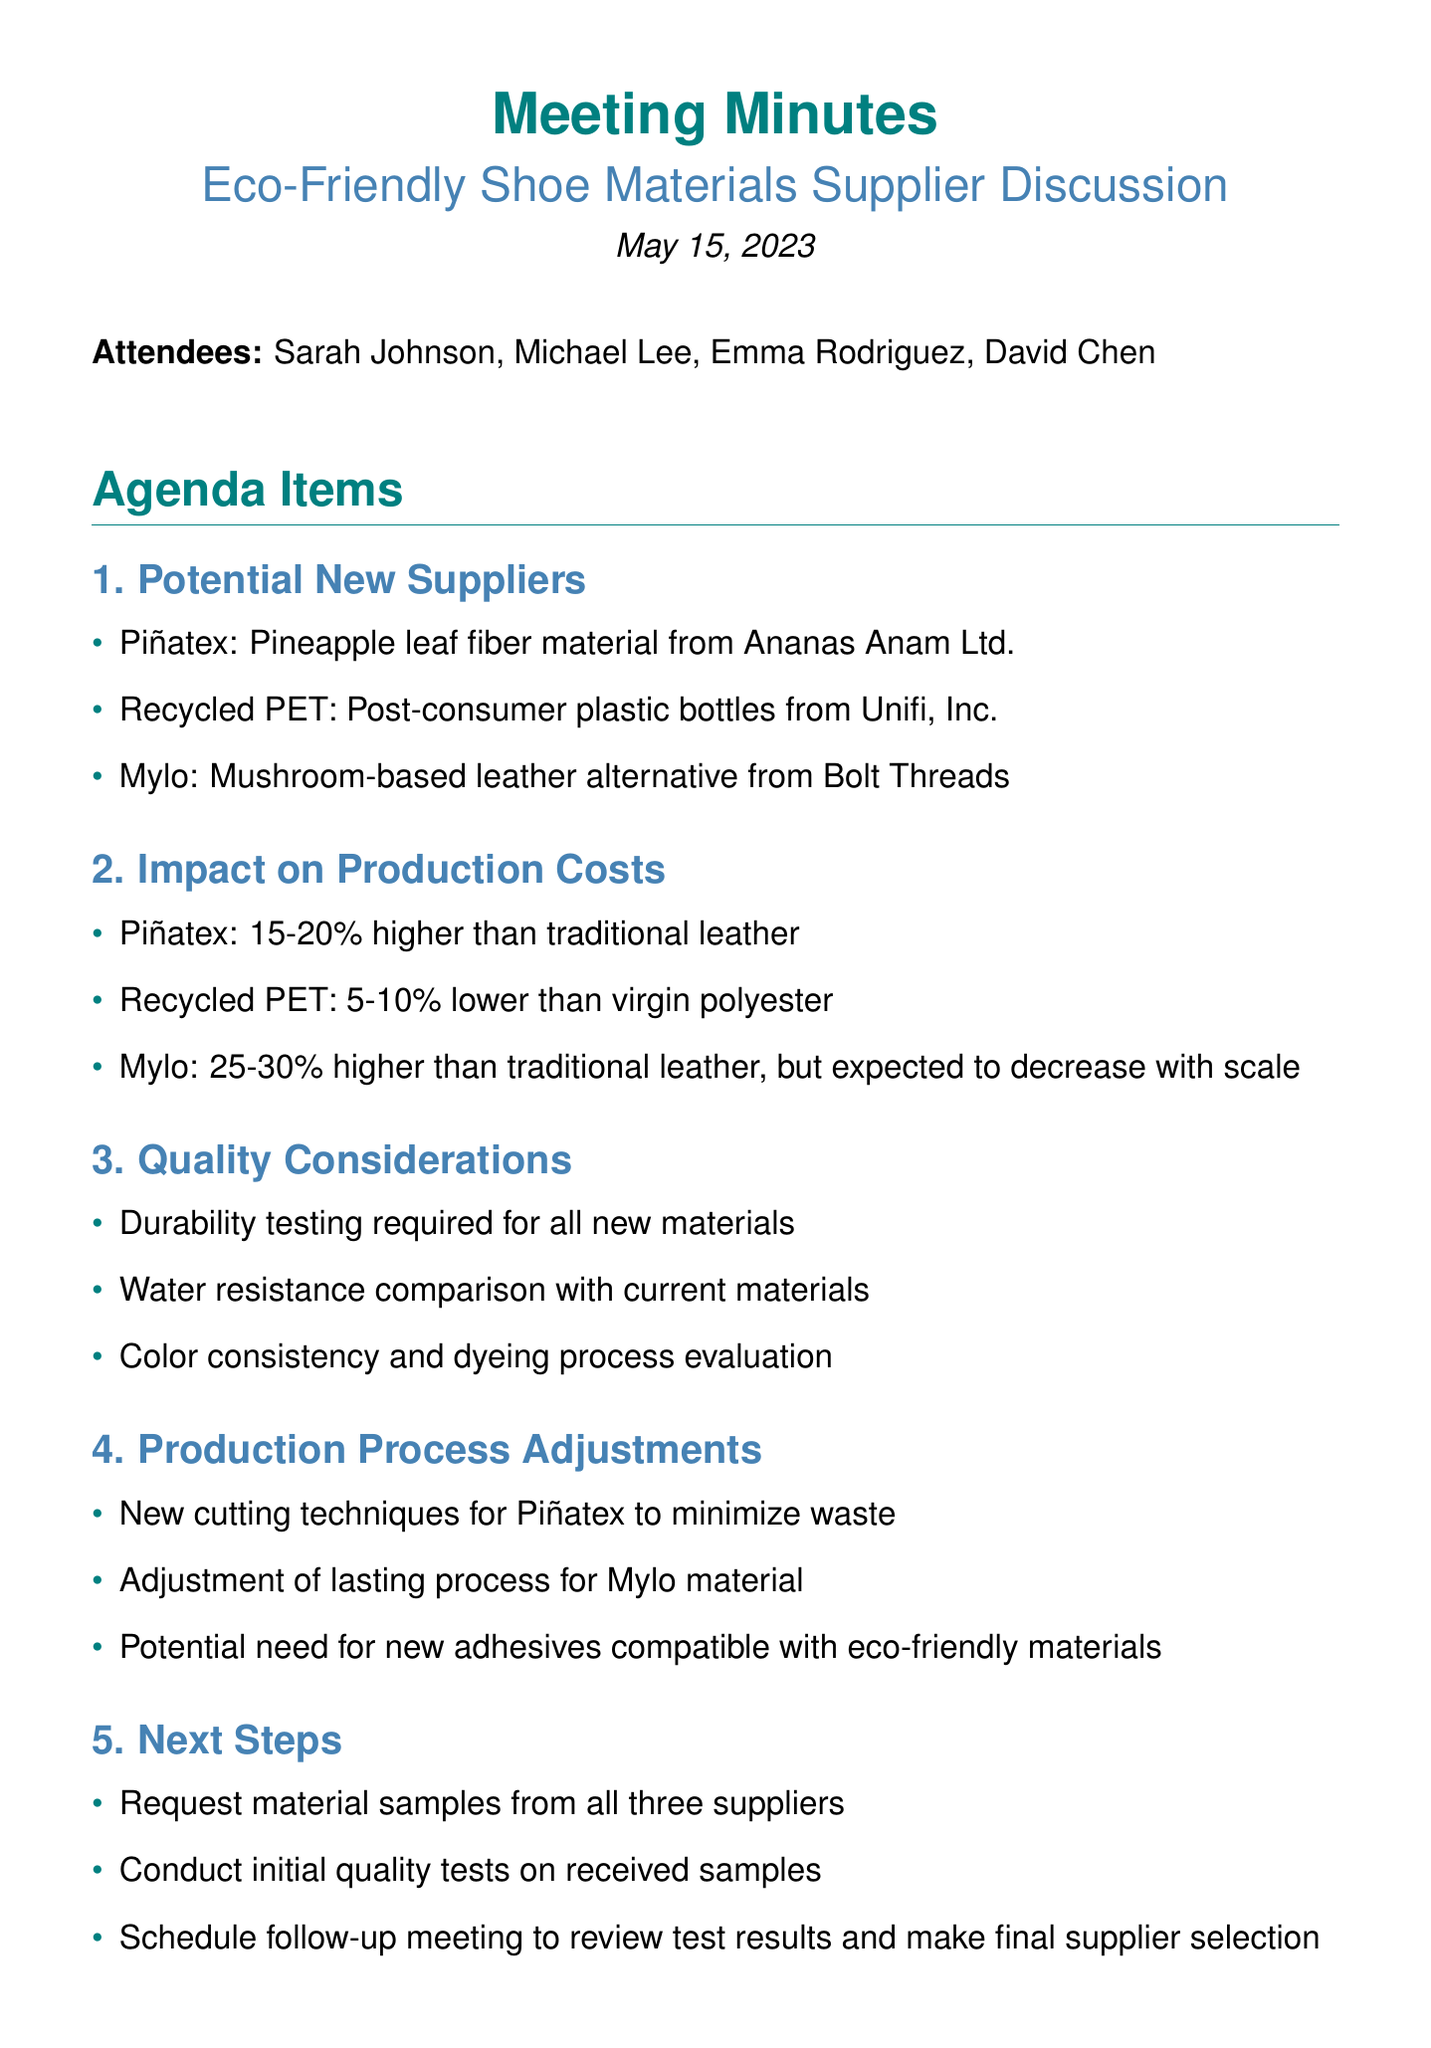What is the meeting title? The meeting title is stated at the beginning of the document, which is "Eco-Friendly Shoe Materials Supplier Discussion."
Answer: Eco-Friendly Shoe Materials Supplier Discussion Who is the Procurement Director? The document lists attendees along with their titles, identifying Michael Lee as the Procurement Director.
Answer: Michael Lee What percentage more expensive is Piñatex compared to traditional leather? The document provides a specific range for the cost of Piñatex against traditional leather, which is 15-20%.
Answer: 15-20% What is the expected cost saving percentage of Recycled PET compared to virgin polyester? The document states that Recycled PET is 5-10% lower than virgin polyester.
Answer: 5-10% What requires durability testing according to the quality considerations? The discussion points mention that durability testing is required for all new materials.
Answer: All new materials What adjustment is required for the lasting process? The document indicates a specific adjustment needed for the lasting process related to the Mylo material.
Answer: Adjustment of lasting process for Mylo material Which material is expected to have a decrease in cost with scale? It is mentioned in the impact on production costs that Mylo is expected to decrease in cost with scale.
Answer: Mylo What are the next steps according to the meeting? The action items in the document outline the next steps which include requesting material samples and conducting initial quality tests.
Answer: Request material samples from all three suppliers How many attendees were present at the meeting? The document lists four individuals as attendees, referring to them by name and title in the attendee list.
Answer: Four 